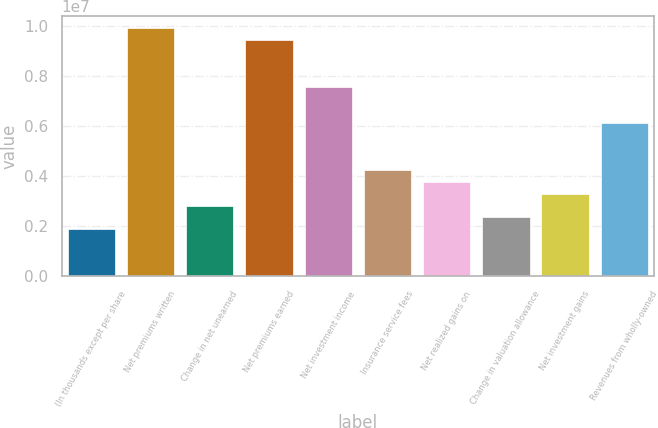Convert chart to OTSL. <chart><loc_0><loc_0><loc_500><loc_500><bar_chart><fcel>(In thousands except per share<fcel>Net premiums written<fcel>Change in net unearned<fcel>Net premiums earned<fcel>Net investment income<fcel>Insurance service fees<fcel>Net realized gains on<fcel>Change in valuation allowance<fcel>Net investment gains<fcel>Revenues from wholly-owned<nl><fcel>1.88963e+06<fcel>9.92054e+06<fcel>2.83444e+06<fcel>9.44814e+06<fcel>7.55851e+06<fcel>4.25166e+06<fcel>3.77926e+06<fcel>2.36204e+06<fcel>3.30685e+06<fcel>6.14129e+06<nl></chart> 